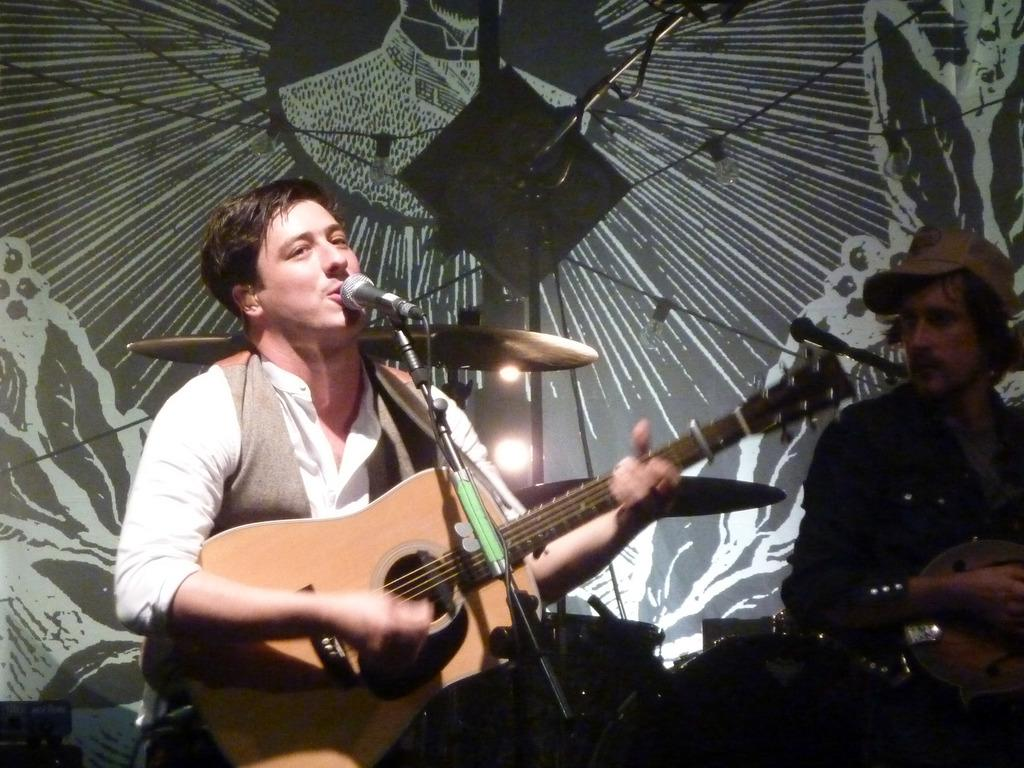How many people are in the image? There are two people in the image. What are the two people doing in the image? The two people are sitting and playing guitar. What other musical instrument can be seen in the image? There are drums visible in the image. How does the ground feel when the person sneezes in the image? There is no person sneezing in the image, and therefore no such interaction with the ground can be observed. What emotion might the two people be expressing while playing guitar in the image? The provided facts do not mention any emotions or feelings of the two people, so it cannot be determined from the image. 